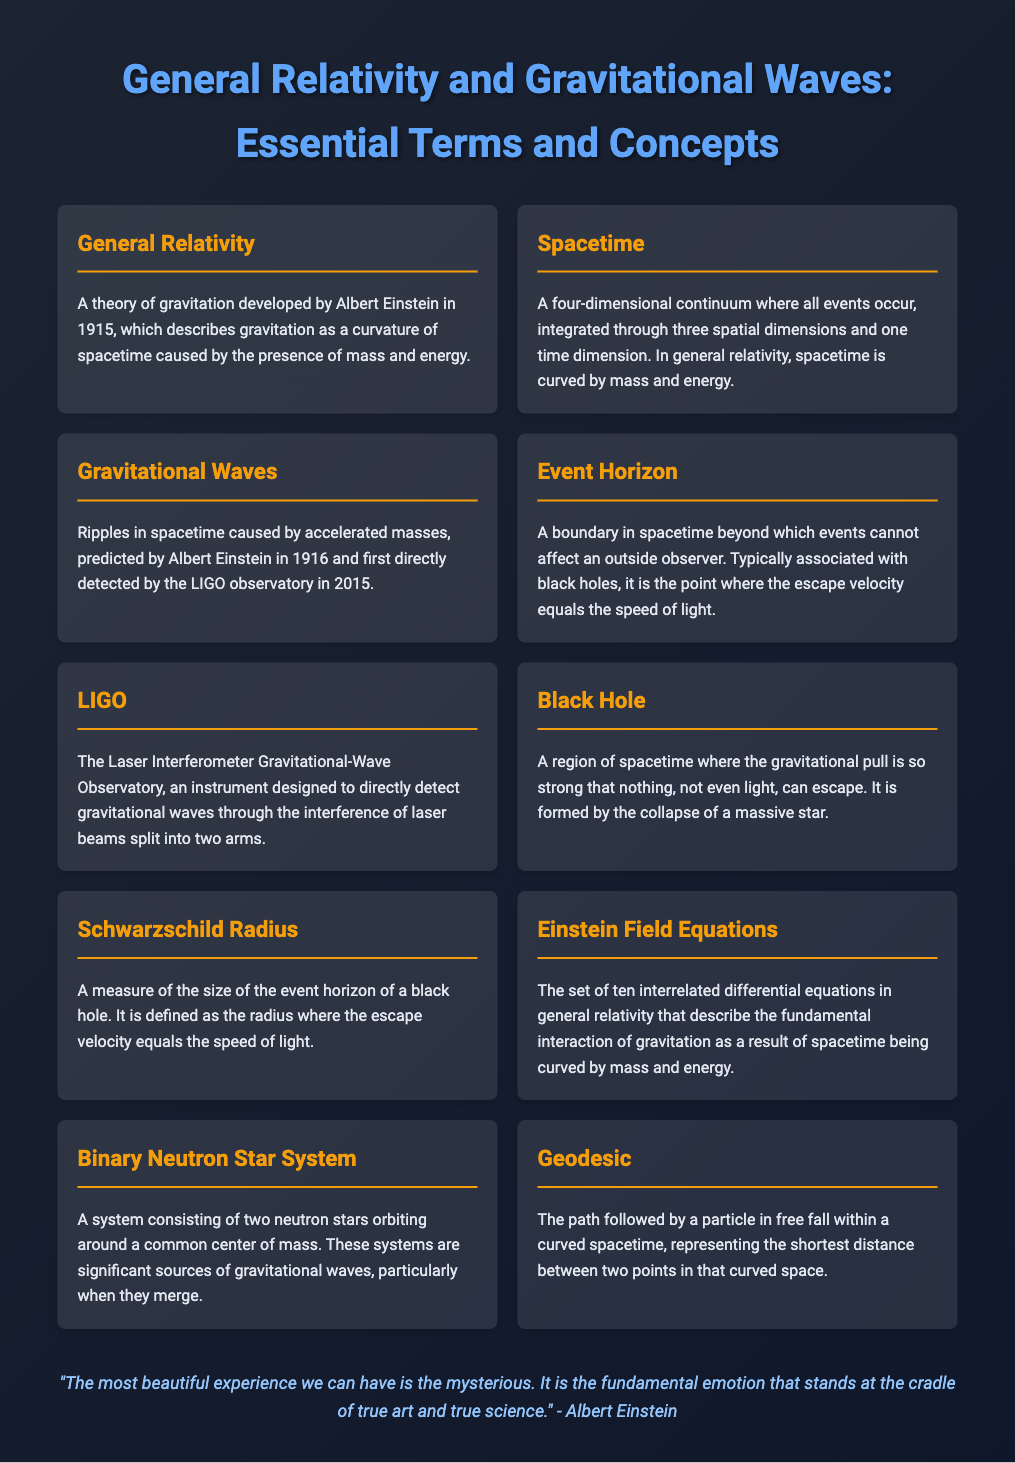What is the title of the document? The title of the document, displayed prominently at the top, is "General Relativity and Gravitational Waves: Essential Terms and Concepts."
Answer: General Relativity and Gravitational Waves: Essential Terms and Concepts Who developed the theory of General Relativity? The text explicitly states that General Relativity was developed by Albert Einstein.
Answer: Albert Einstein When were gravitational waves first detected? The document mentions that gravitational waves were first directly detected in 2015.
Answer: 2015 What is the significance of the Schwarzschild Radius? The definition of the Schwarzschild Radius describes it as a measure of the size of the event horizon of a black hole.
Answer: Size of the event horizon What do the Einstein Field Equations describe? The description indicates that the Einstein Field Equations describe the interaction of gravitation as a result of spacetime being curved by mass and energy.
Answer: The fundamental interaction of gravitation How does spacetime relate to mass and energy? The document states that in general relativity, spacetime is curved by mass and energy.
Answer: Curved by mass and energy What kind of observatory is LIGO? The text identifies LIGO as the Laser Interferometer Gravitational-Wave Observatory.
Answer: Laser Interferometer Gravitational-Wave Observatory What event can happen beyond the Event Horizon? The document defines the Event Horizon as a boundary beyond which events cannot affect an outside observer.
Answer: Events cannot affect an outside observer What path is followed by a particle in free fall called? According to the glossary, the path followed by a particle in free fall is called a geodesic.
Answer: Geodesic 